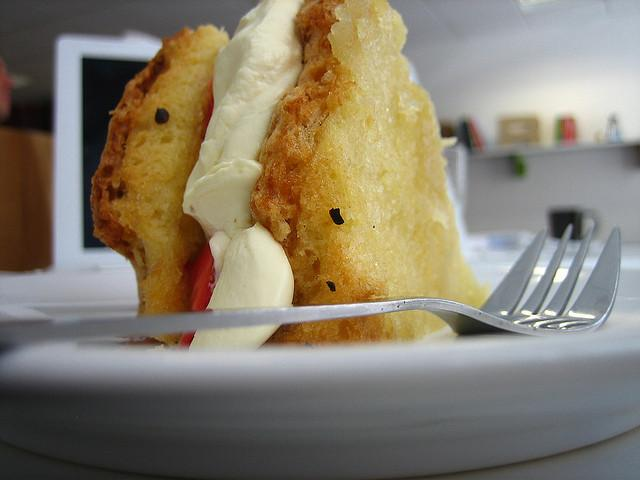What type of fork is included with the meal? Please explain your reasoning. dessert. The fork is for dessert. 